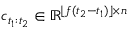Convert formula to latex. <formula><loc_0><loc_0><loc_500><loc_500>c _ { t _ { 1 } \colon t _ { 2 } } \in \mathbb { R } ^ { \lfloor f ( t _ { 2 } - t _ { 1 } ) \rfloor \times n }</formula> 